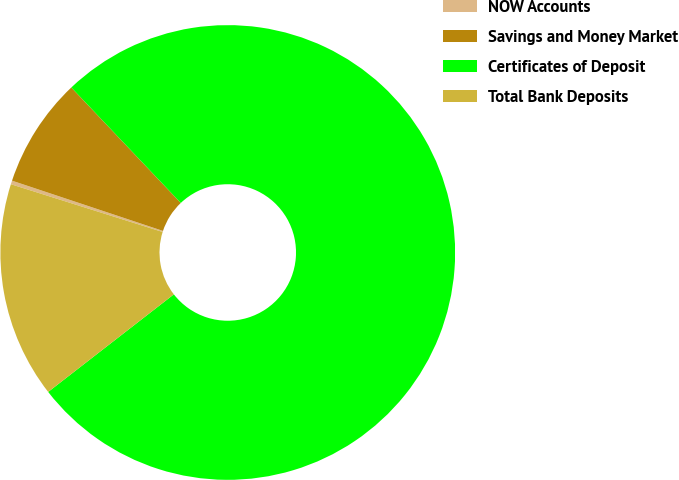<chart> <loc_0><loc_0><loc_500><loc_500><pie_chart><fcel>NOW Accounts<fcel>Savings and Money Market<fcel>Certificates of Deposit<fcel>Total Bank Deposits<nl><fcel>0.26%<fcel>7.81%<fcel>76.56%<fcel>15.36%<nl></chart> 